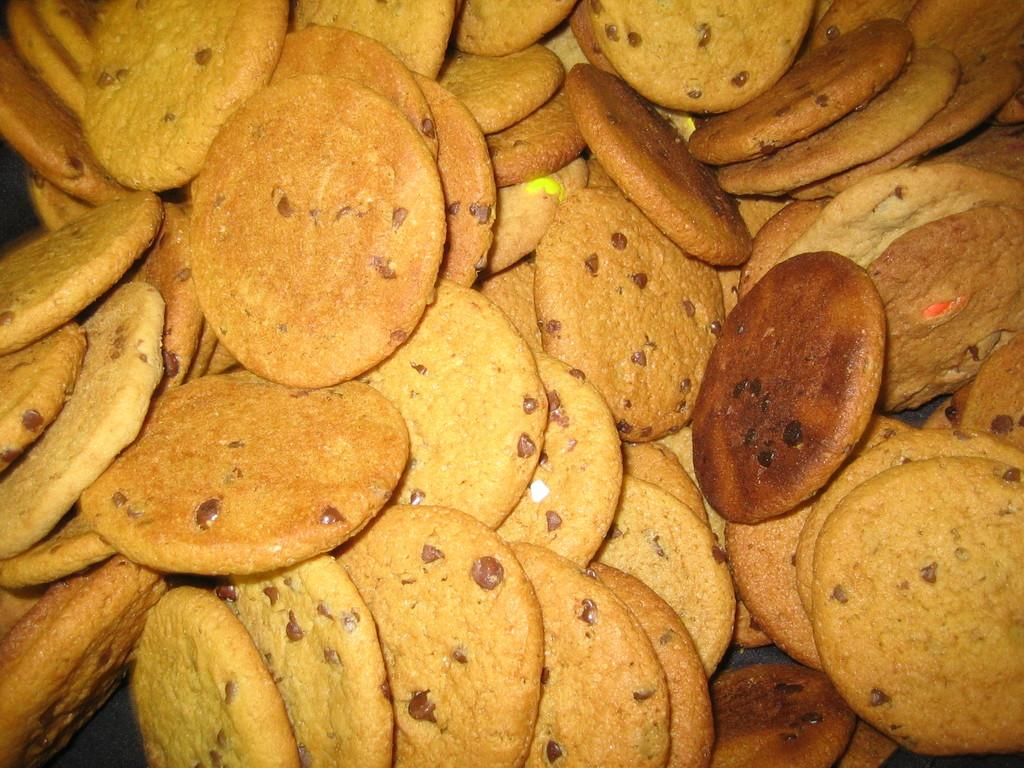What type of food can be seen in the image? There are cookies in the image. Is there a veil covering the cookies in the image? No, there is no veil present in the image. 